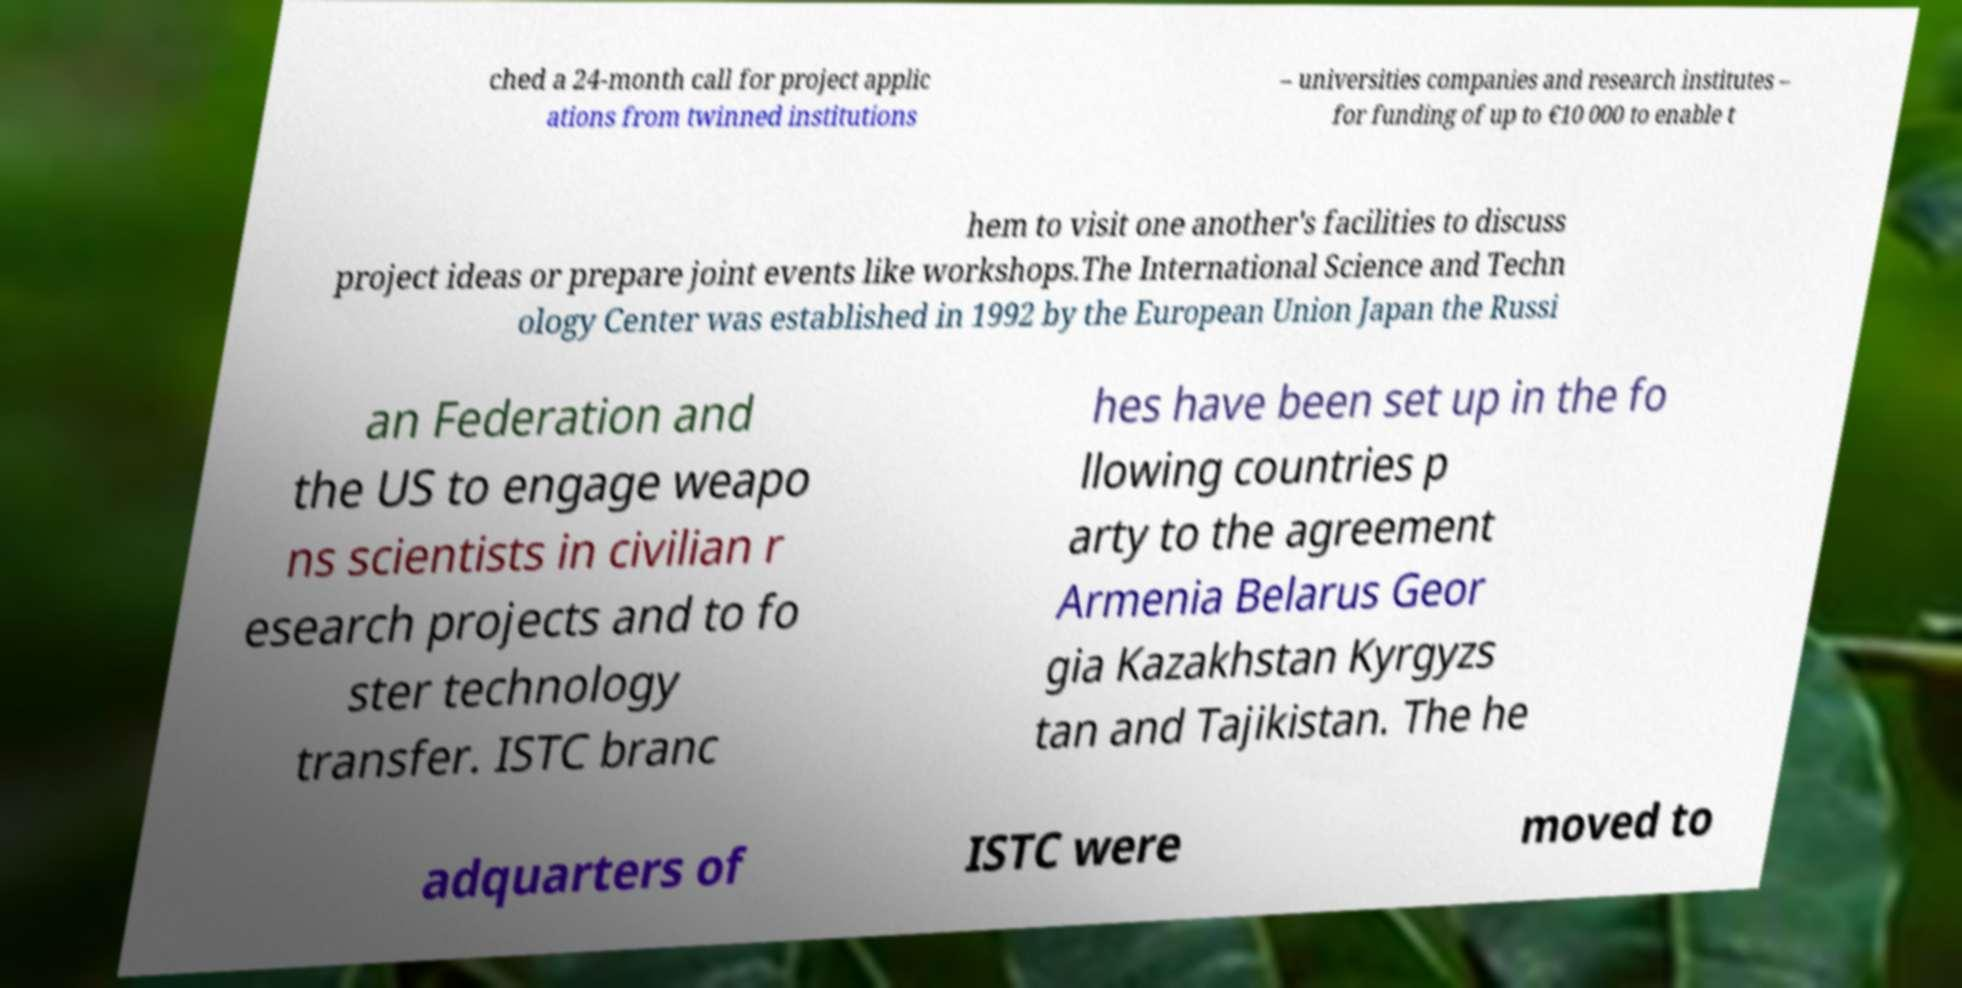Could you extract and type out the text from this image? ched a 24-month call for project applic ations from twinned institutions – universities companies and research institutes – for funding of up to €10 000 to enable t hem to visit one another's facilities to discuss project ideas or prepare joint events like workshops.The International Science and Techn ology Center was established in 1992 by the European Union Japan the Russi an Federation and the US to engage weapo ns scientists in civilian r esearch projects and to fo ster technology transfer. ISTC branc hes have been set up in the fo llowing countries p arty to the agreement Armenia Belarus Geor gia Kazakhstan Kyrgyzs tan and Tajikistan. The he adquarters of ISTC were moved to 